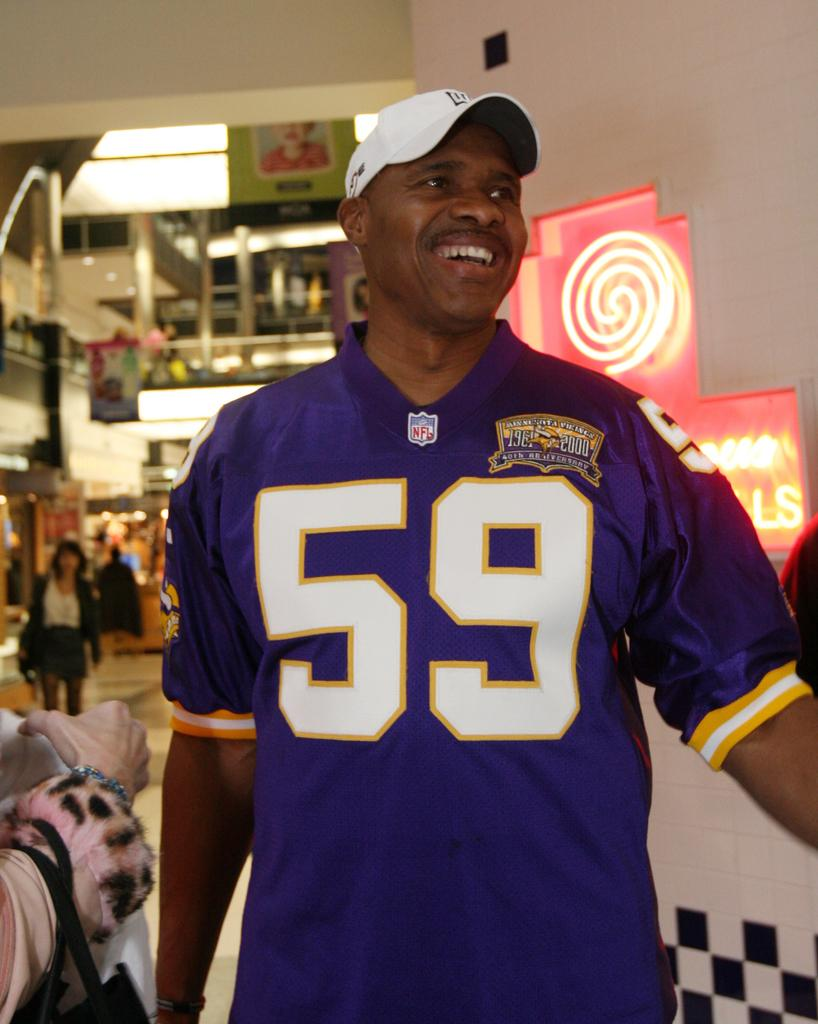Provide a one-sentence caption for the provided image. Black man wearing a jersey from the NFL with number 59 wrote on it. 